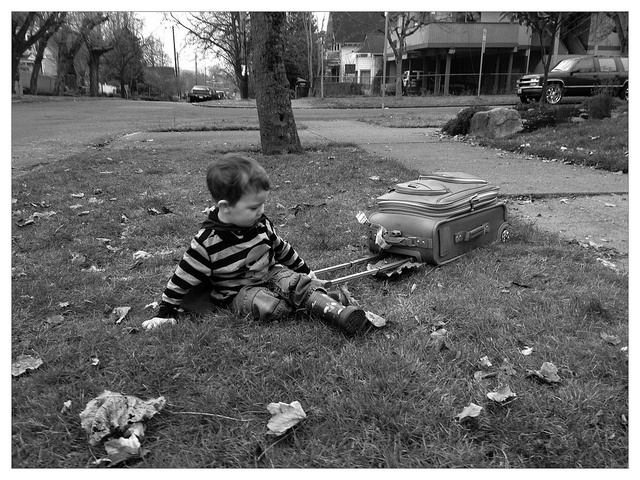Describe the objects in this image and their specific colors. I can see people in white, black, gray, darkgray, and lightgray tones, suitcase in white, gray, darkgray, black, and lightgray tones, car in white, black, gray, darkgray, and lightgray tones, car in white, black, gray, darkgray, and gainsboro tones, and car in black and white tones in this image. 